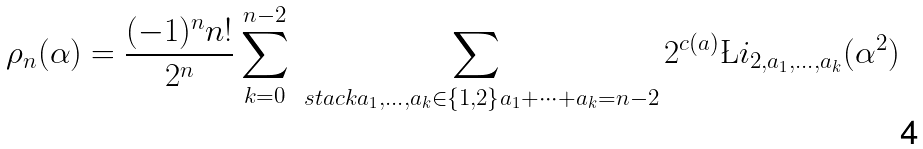Convert formula to latex. <formula><loc_0><loc_0><loc_500><loc_500>\rho _ { n } ( \alpha ) = \frac { ( - 1 ) ^ { n } n ! } { 2 ^ { n } } \sum _ { k = 0 } ^ { n - 2 } \sum _ { \ s t a c k { a _ { 1 } , \dots , a _ { k } \in \{ 1 , 2 \} } { a _ { 1 } + \dots + a _ { k } = n - 2 } } 2 ^ { c ( a ) } \L i _ { 2 , a _ { 1 } , \dots , a _ { k } } ( \alpha ^ { 2 } )</formula> 